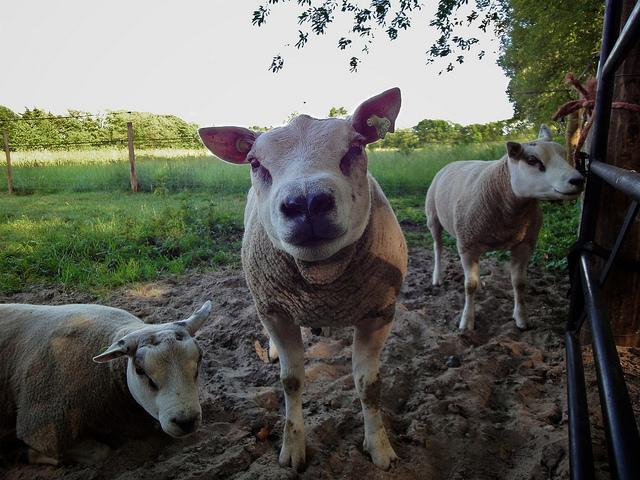Which indoor domestic animal does the center sheep resemble? dog 